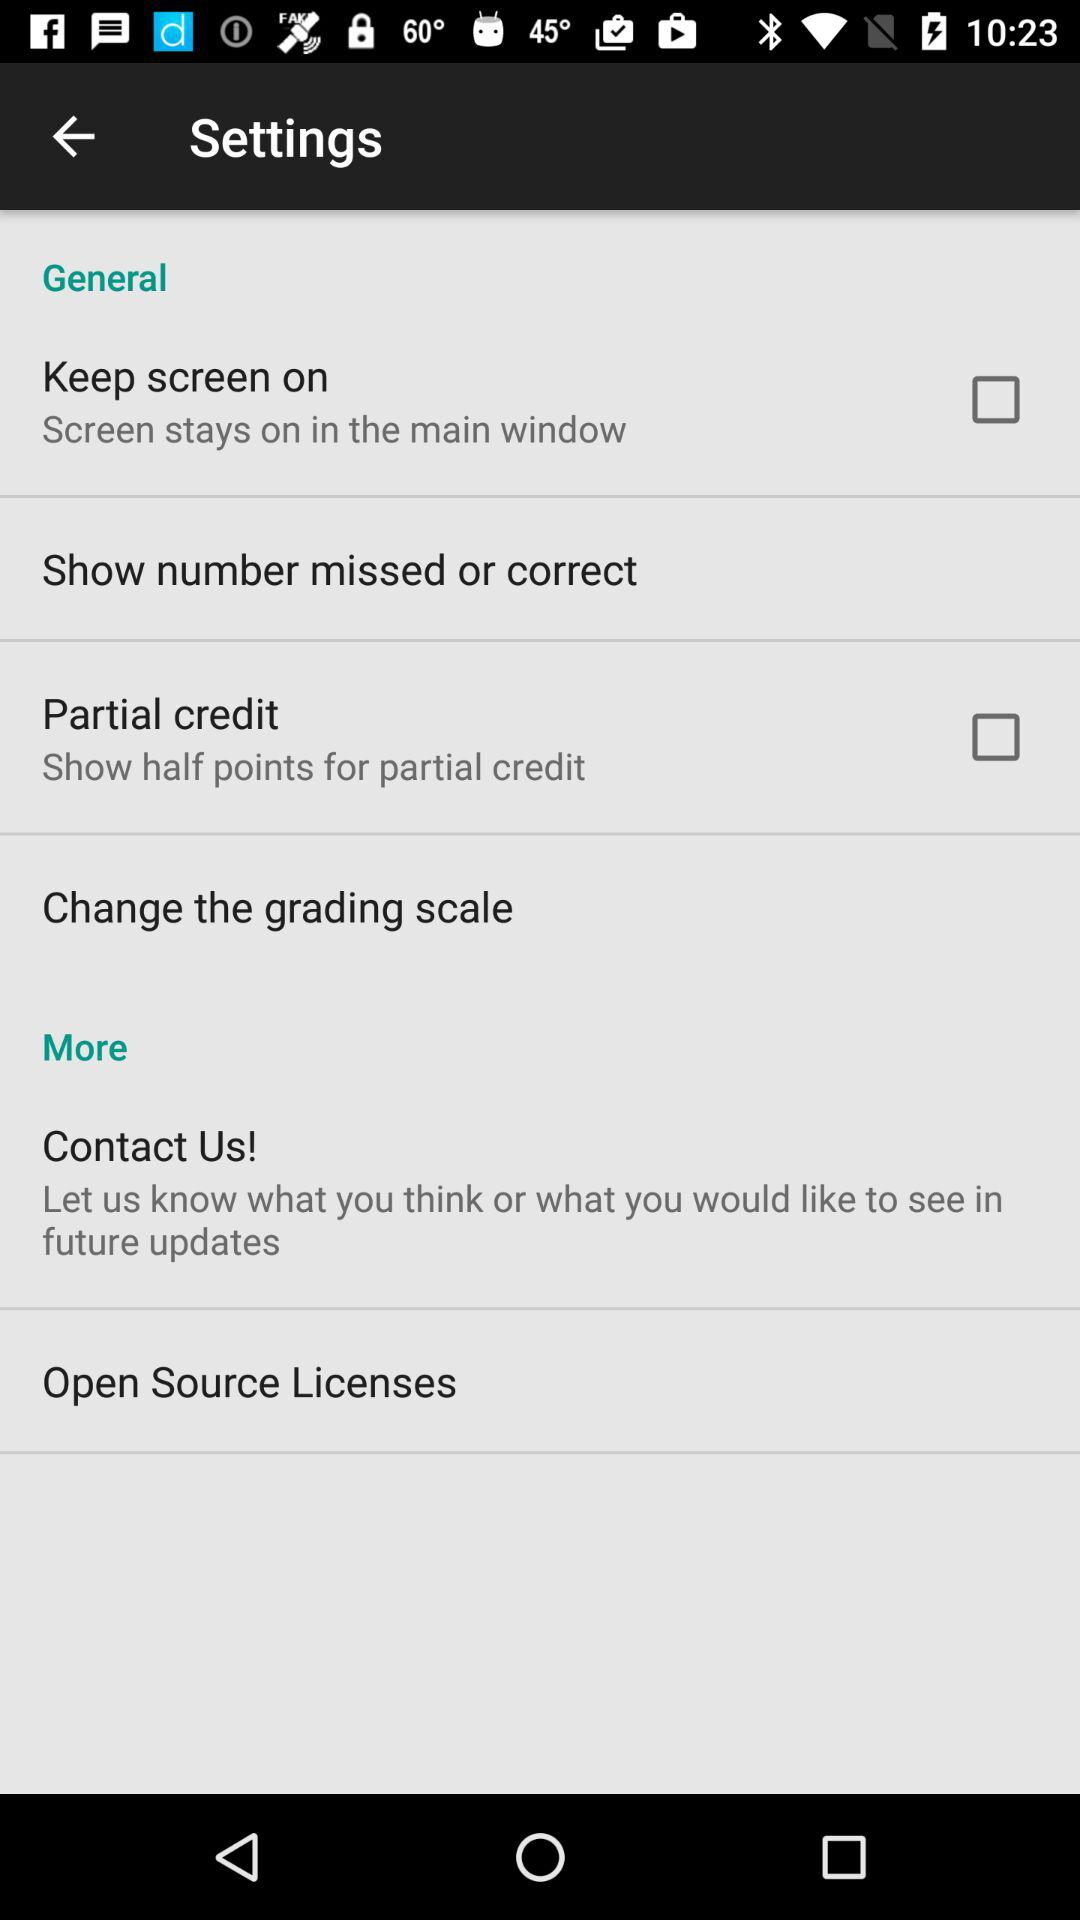How many items in the Settings menu have a checkbox?
Answer the question using a single word or phrase. 2 